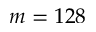<formula> <loc_0><loc_0><loc_500><loc_500>m = 1 2 8</formula> 